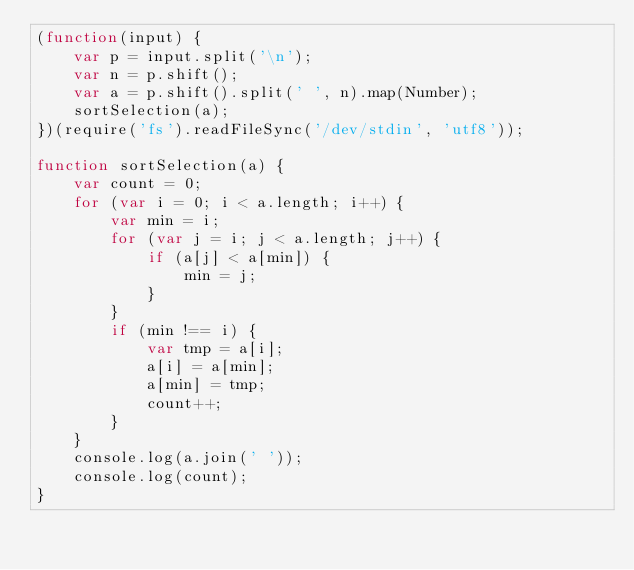Convert code to text. <code><loc_0><loc_0><loc_500><loc_500><_JavaScript_>(function(input) {
    var p = input.split('\n');
    var n = p.shift();
    var a = p.shift().split(' ', n).map(Number);
    sortSelection(a);
})(require('fs').readFileSync('/dev/stdin', 'utf8'));

function sortSelection(a) {
    var count = 0;
    for (var i = 0; i < a.length; i++) {
        var min = i;
        for (var j = i; j < a.length; j++) {
            if (a[j] < a[min]) {
                min = j;
            }
        }
        if (min !== i) {
            var tmp = a[i];
            a[i] = a[min];
            a[min] = tmp;
            count++;
        }
    }
    console.log(a.join(' '));
    console.log(count);
}</code> 